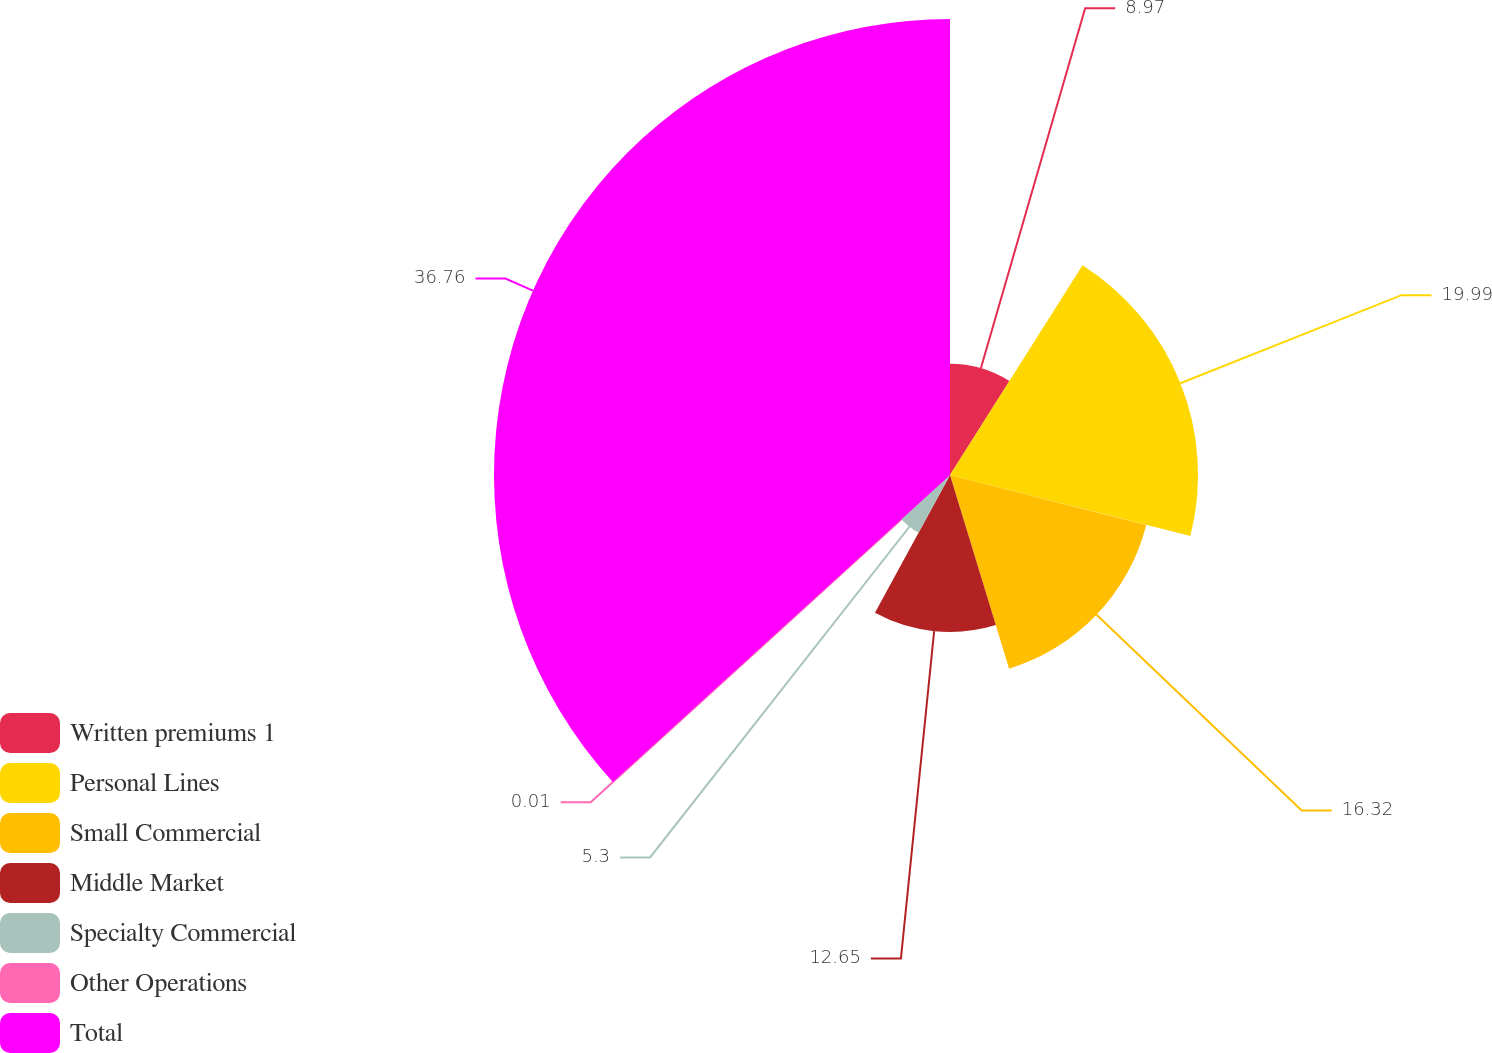<chart> <loc_0><loc_0><loc_500><loc_500><pie_chart><fcel>Written premiums 1<fcel>Personal Lines<fcel>Small Commercial<fcel>Middle Market<fcel>Specialty Commercial<fcel>Other Operations<fcel>Total<nl><fcel>8.97%<fcel>19.99%<fcel>16.32%<fcel>12.65%<fcel>5.3%<fcel>0.01%<fcel>36.75%<nl></chart> 